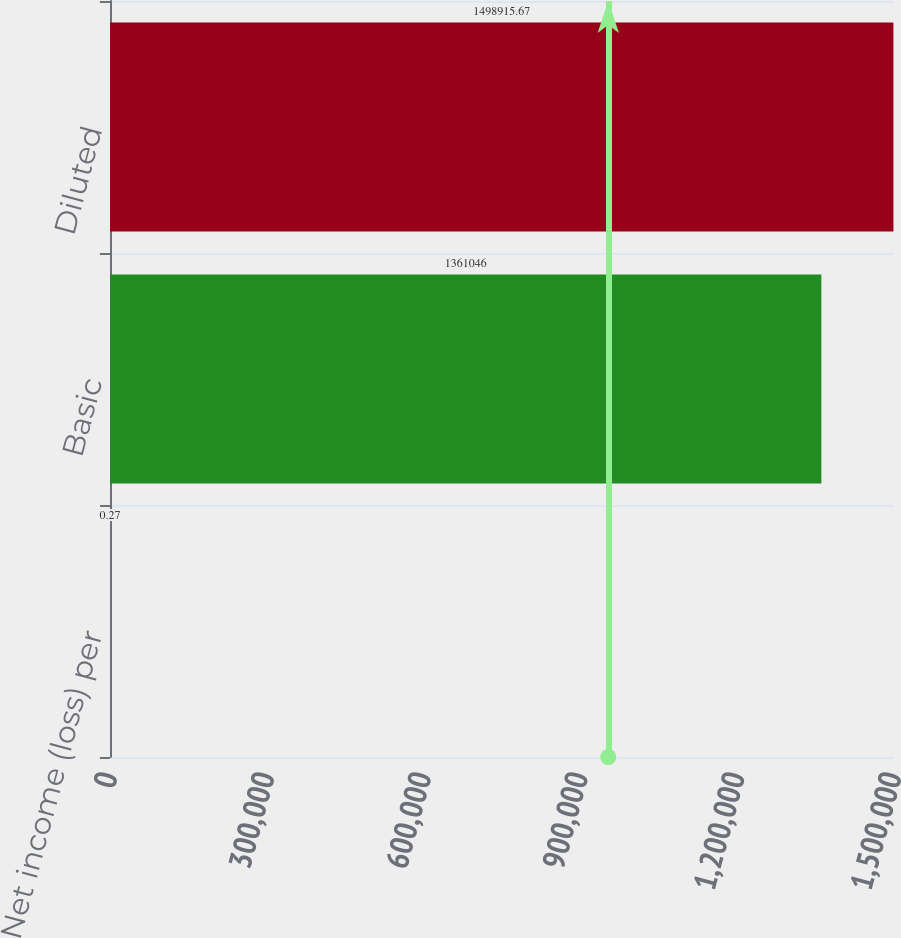Convert chart to OTSL. <chart><loc_0><loc_0><loc_500><loc_500><bar_chart><fcel>Net income (loss) per<fcel>Basic<fcel>Diluted<nl><fcel>0.27<fcel>1.36105e+06<fcel>1.49892e+06<nl></chart> 